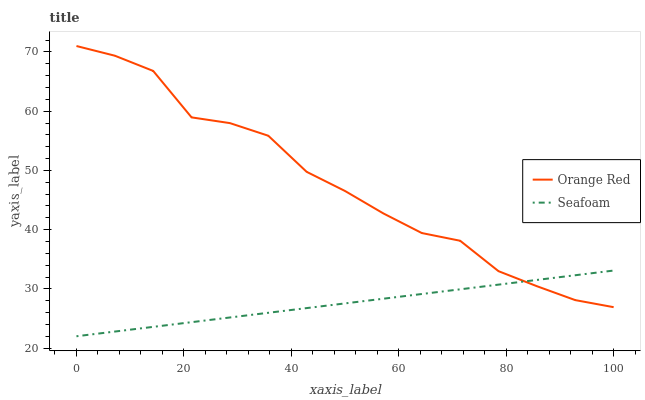Does Seafoam have the minimum area under the curve?
Answer yes or no. Yes. Does Orange Red have the maximum area under the curve?
Answer yes or no. Yes. Does Seafoam have the maximum area under the curve?
Answer yes or no. No. Is Seafoam the smoothest?
Answer yes or no. Yes. Is Orange Red the roughest?
Answer yes or no. Yes. Is Seafoam the roughest?
Answer yes or no. No. Does Seafoam have the lowest value?
Answer yes or no. Yes. Does Orange Red have the highest value?
Answer yes or no. Yes. Does Seafoam have the highest value?
Answer yes or no. No. Does Orange Red intersect Seafoam?
Answer yes or no. Yes. Is Orange Red less than Seafoam?
Answer yes or no. No. Is Orange Red greater than Seafoam?
Answer yes or no. No. 